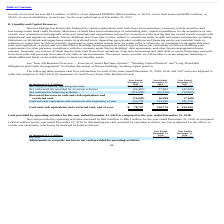According to Navios Maritime Holdings's financial document, What was the change in Net cash provided by operating activities between 2018 and 2019? According to the financial document, 40.5 (in millions). The relevant text states: "sh provided by operating activities increased by $40.5 million to $96.1 million for the year ended December 31, 2019, as compared..." Also, Which years does the table provide information for cash flow? The document contains multiple relevant values: 2019, 2018, 2017. From the document: "h case, for the year ended and as of December 31, 2017. ormation for each of the years ended December 31, 2019, 2018, and 2017 and were adjusted to on..." Also, What was the net cash used in financing activities in 2019? According to the financial document, (111,692) (in thousands). The relevant text states: "Net cash used in financing activities (111,692) (66,916) (12,940)..." Also, How many years did the Cash and cash equivalents and restricted cash, beginning of year exceed $150,000 thousand? Based on the analysis, there are 1 instances. The counting process: 2019. Also, can you calculate: What was the change in Net cash  provided by investing activities between 2017 and 2019? Based on the calculation: -56,467-(-42,365), the result is -14102 (in thousands). This is based on the information: "cash (used in)/ provided by investing activities (56,467) 27,863 (42,365) provided by investing activities (56,467) 27,863 (42,365)..." The key data points involved are: 42,365, 56,467. Also, can you calculate: What was the percentage change in the Net cash provided by operating activities between 2017 and 2018? To answer this question, I need to perform calculations using the financial data. The calculation is: (55,637-48,117)/48,117, which equals 15.63 (percentage). This is based on the information: "cash provided by operating activities $ 96,112 $ 55,637 $ 48,117 vided by operating activities $ 96,112 $ 55,637 $ 48,117..." The key data points involved are: 48,117, 55,637. 